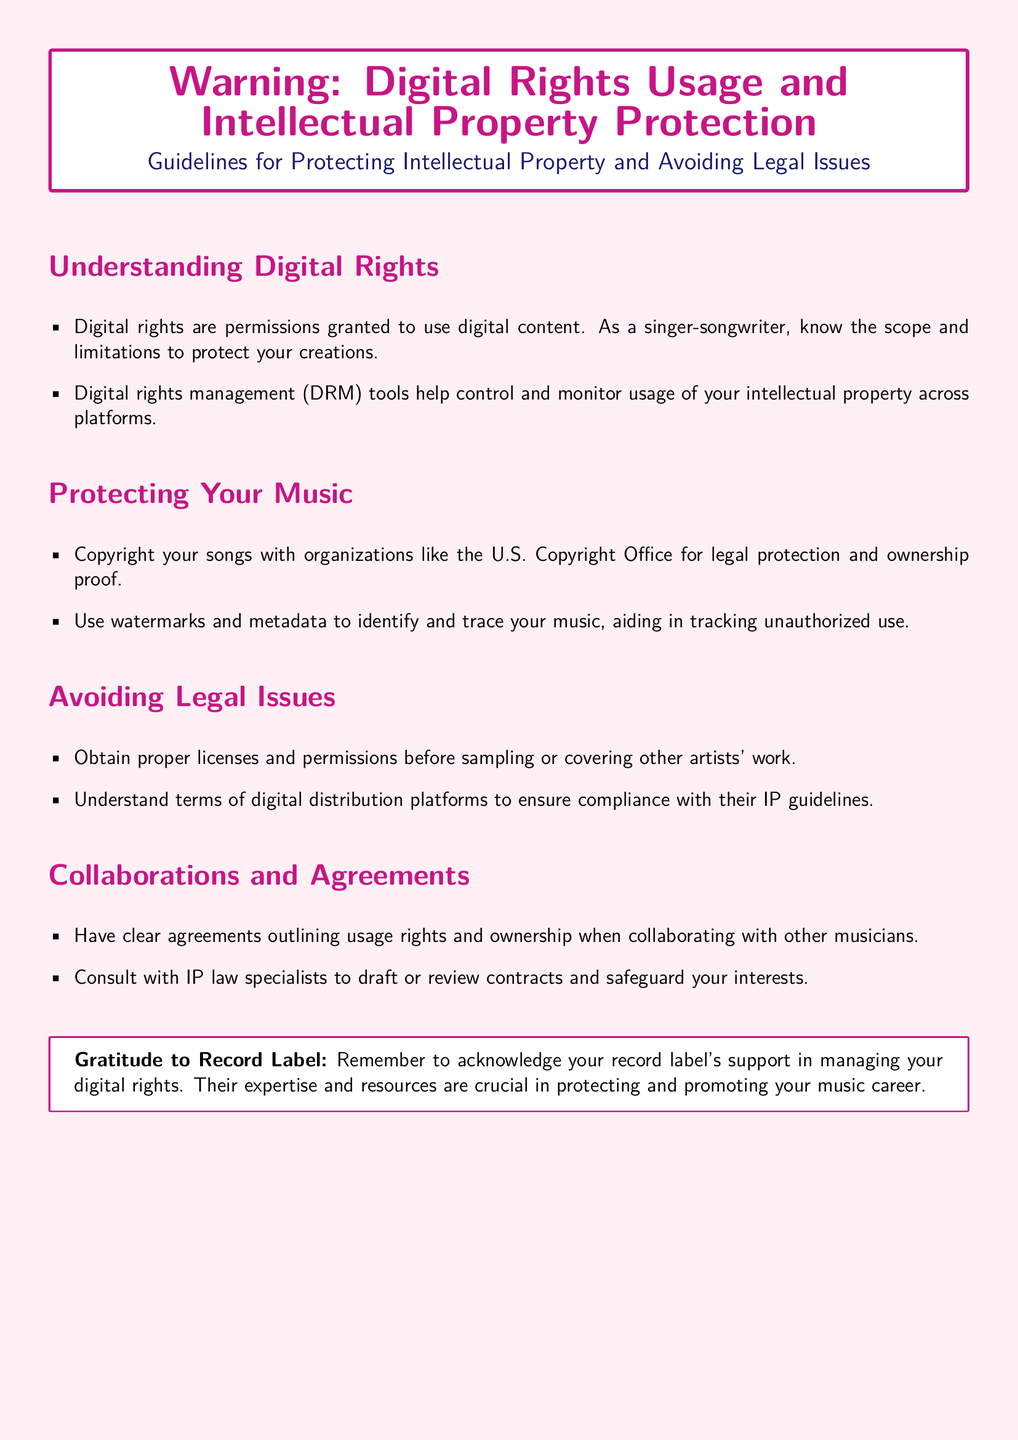What are digital rights? Digital rights are permissions granted to use digital content, and as a singer-songwriter, it's important to know the scope and limitations to protect creations.
Answer: Permissions granted to use digital content What organization suggests copyrighting songs for protection? The U.S. Copyright Office is mentioned as an organization that provides legal protection and ownership proof for songs.
Answer: U.S. Copyright Office What should you use to track unauthorized music usage? Watermarks and metadata are tools suggested to identify and trace your music, aiding in tracking unauthorized use.
Answer: Watermarks and metadata What is essential before sampling or covering music? Obtaining proper licenses and permissions is crucial before sampling or covering other artists' work to avoid legal issues.
Answer: Proper licenses and permissions What should be outlined in collaborations? Clear agreements outlining usage rights and ownership should be established when collaborating with other musicians.
Answer: Usage rights and ownership Who should be consulted for drafting contracts? IP law specialists should be consulted to draft or review contracts to safeguard interests in music.
Answer: IP law specialists What color is used for the background of the document? The background color of the document is a light pinkish shade, indicated as warning color.
Answer: Pinkish shade What is emphasized in the gratitude section? The gratitude section emphasizes acknowledging the record label's support in managing digital rights.
Answer: Acknowledging record label's support 